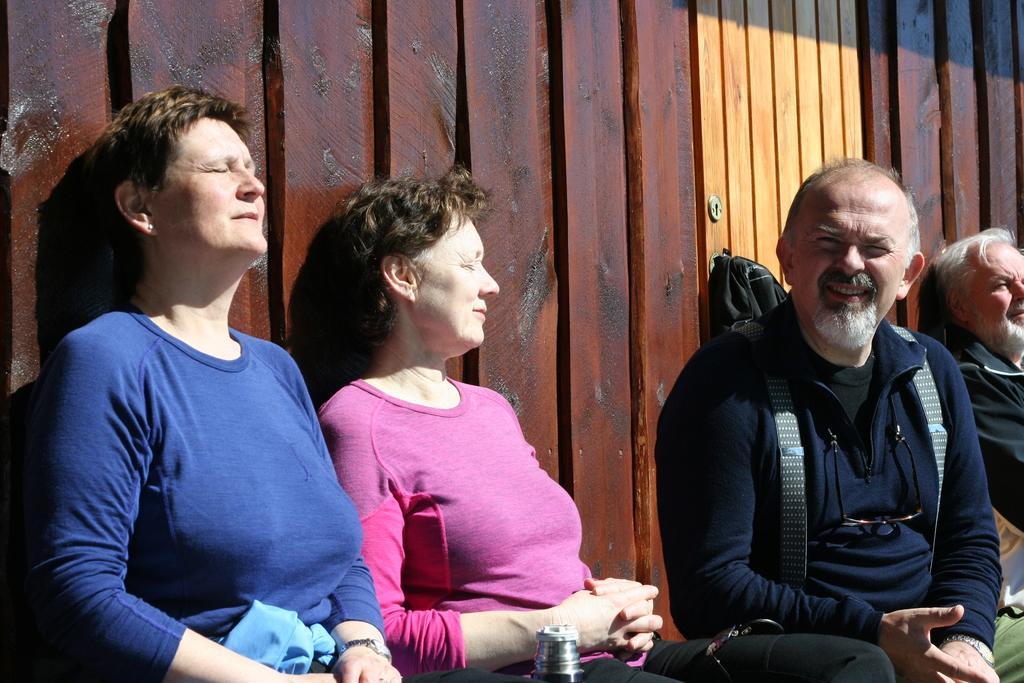Please provide a concise description of this image. In this picture we can see four people, here we can see an object and in the background we can see wooden planks. 